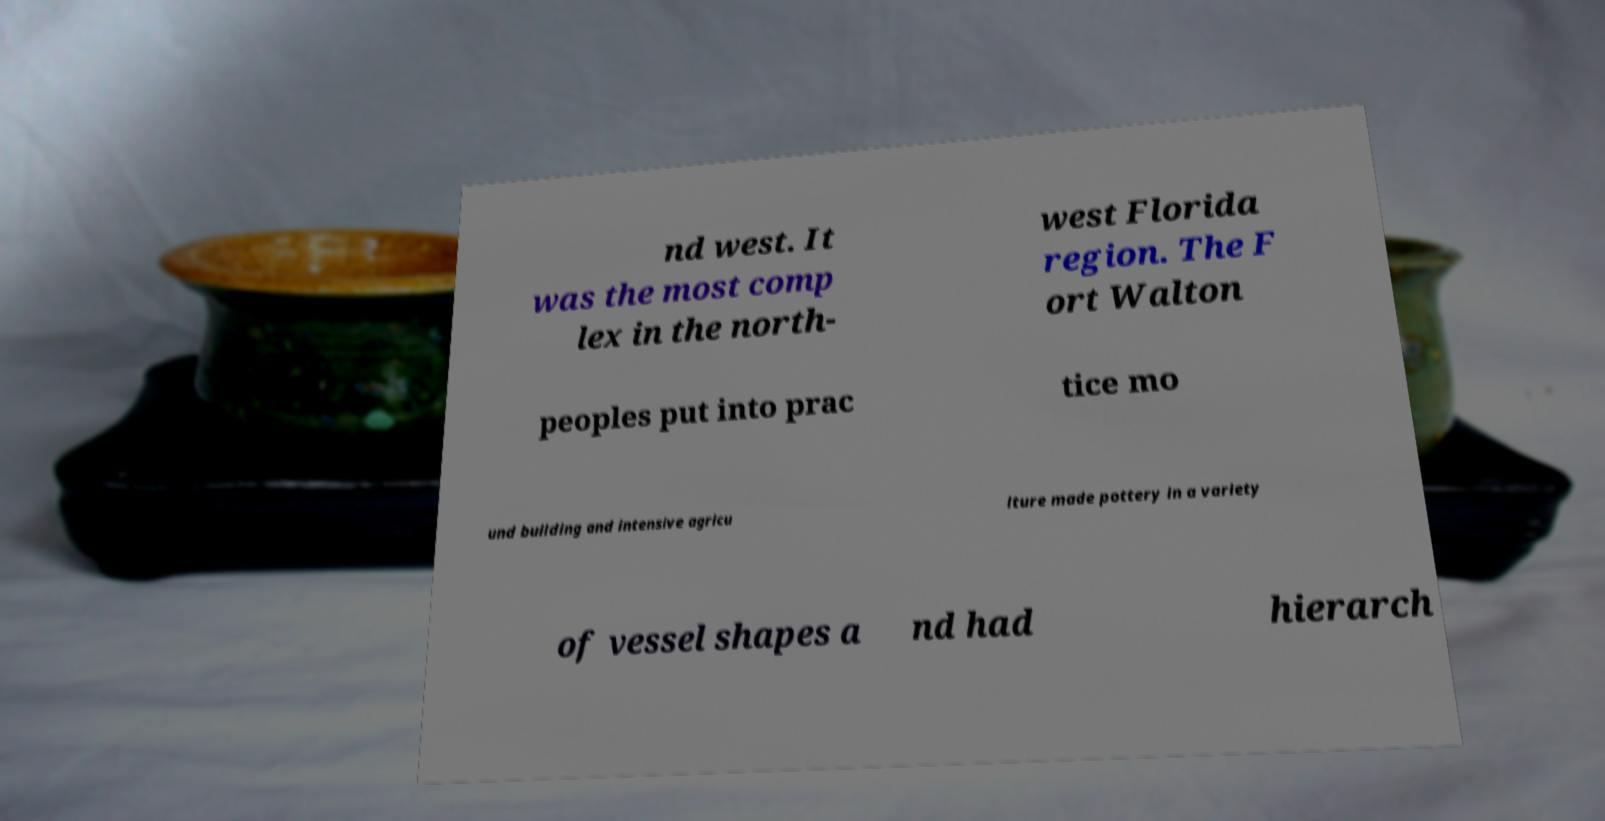Please read and relay the text visible in this image. What does it say? nd west. It was the most comp lex in the north- west Florida region. The F ort Walton peoples put into prac tice mo und building and intensive agricu lture made pottery in a variety of vessel shapes a nd had hierarch 